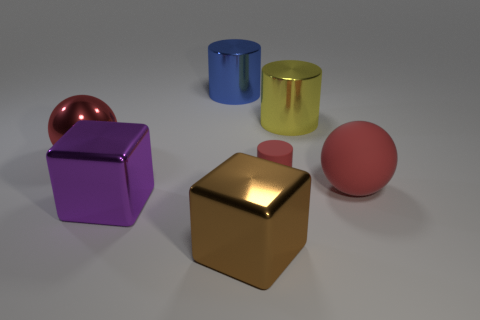Add 1 large metal balls. How many objects exist? 8 Subtract all cylinders. How many objects are left? 4 Add 1 gray shiny spheres. How many gray shiny spheres exist? 1 Subtract 0 gray spheres. How many objects are left? 7 Subtract all brown blocks. Subtract all tiny matte objects. How many objects are left? 5 Add 6 big blue metallic objects. How many big blue metallic objects are left? 7 